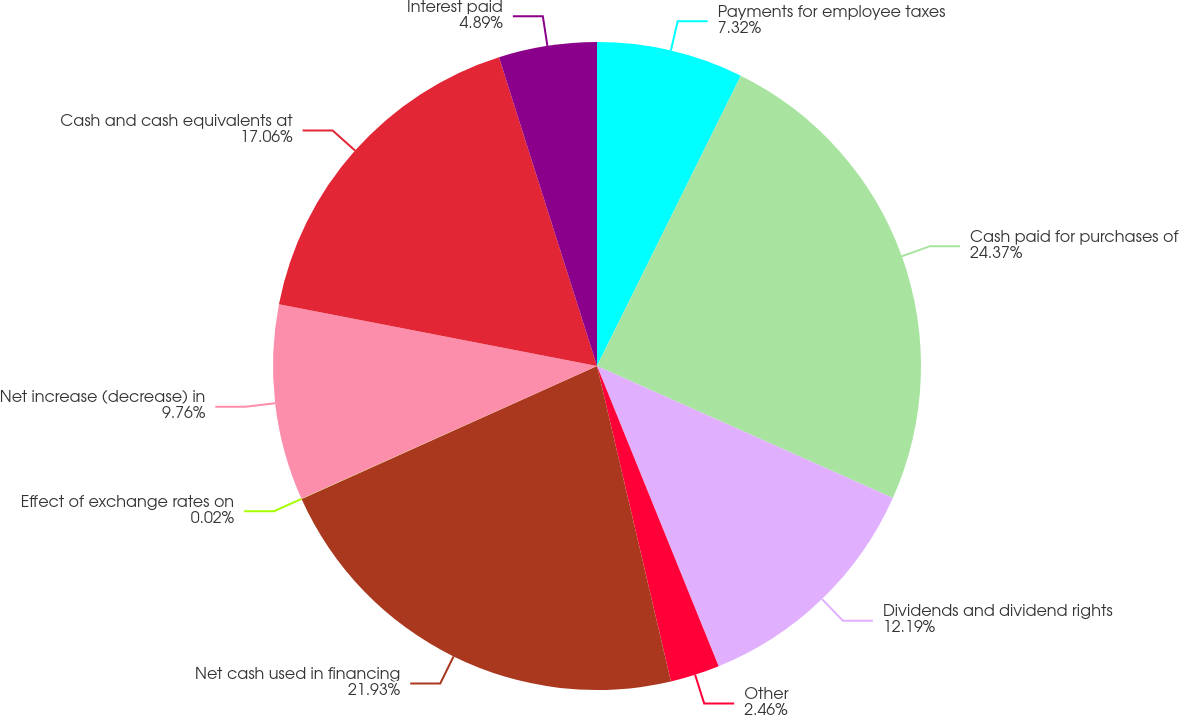Convert chart. <chart><loc_0><loc_0><loc_500><loc_500><pie_chart><fcel>Payments for employee taxes<fcel>Cash paid for purchases of<fcel>Dividends and dividend rights<fcel>Other<fcel>Net cash used in financing<fcel>Effect of exchange rates on<fcel>Net increase (decrease) in<fcel>Cash and cash equivalents at<fcel>Interest paid<nl><fcel>7.32%<fcel>24.36%<fcel>12.19%<fcel>2.46%<fcel>21.93%<fcel>0.02%<fcel>9.76%<fcel>17.06%<fcel>4.89%<nl></chart> 